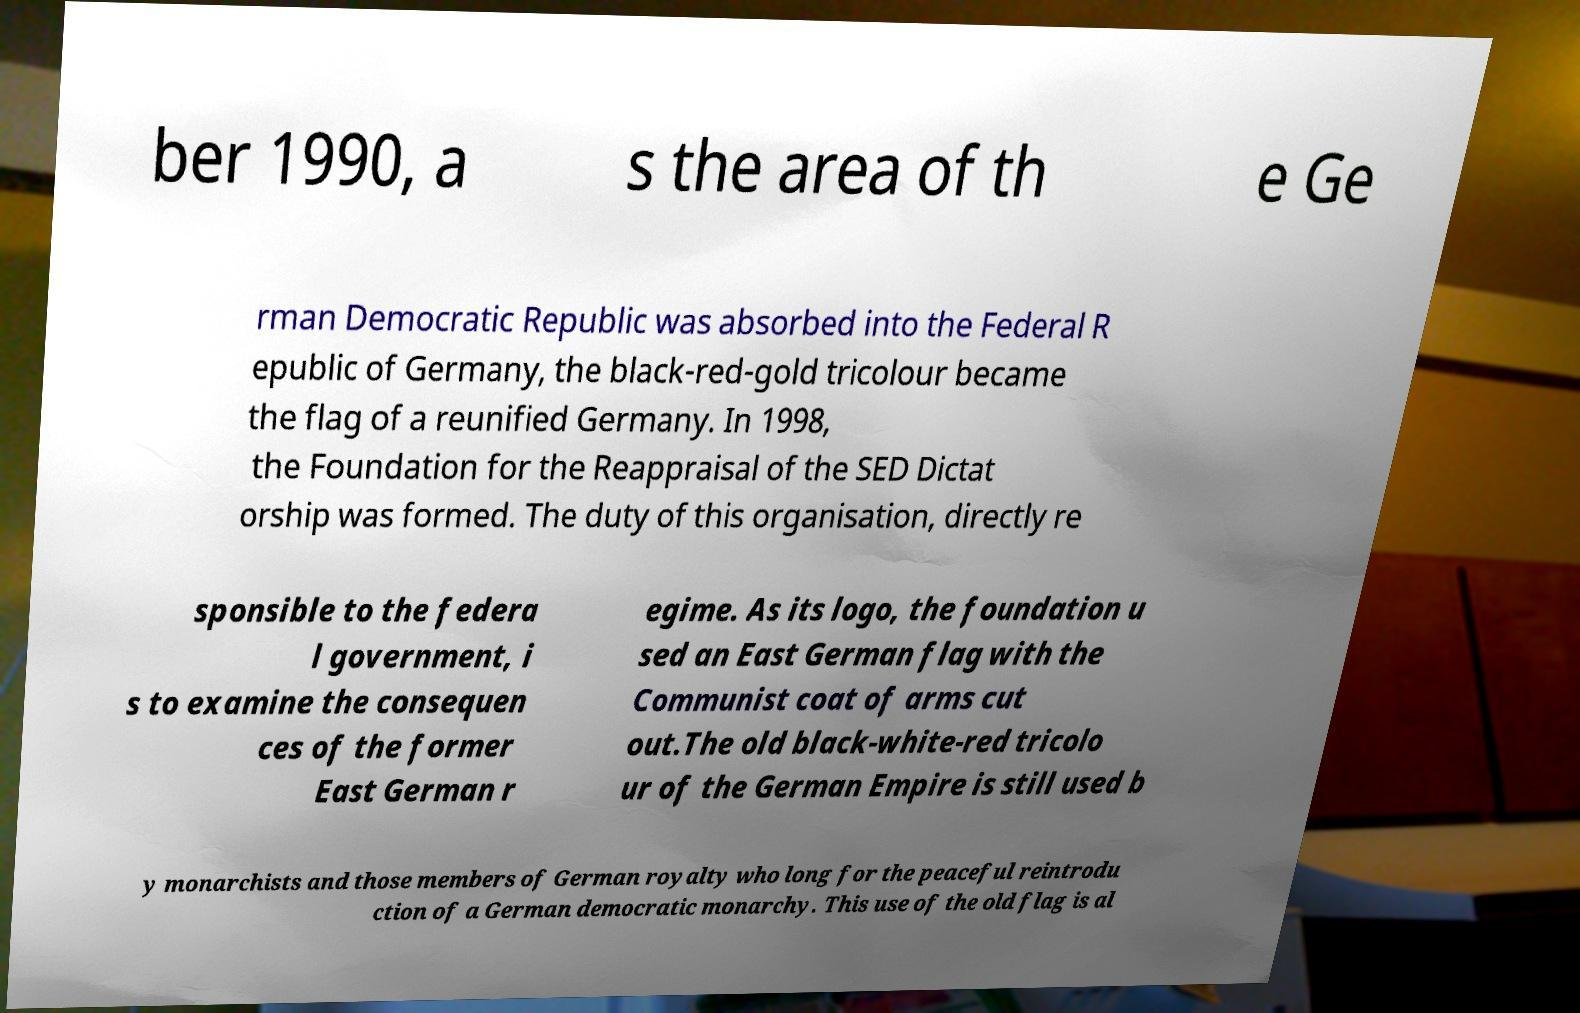Could you extract and type out the text from this image? ber 1990, a s the area of th e Ge rman Democratic Republic was absorbed into the Federal R epublic of Germany, the black-red-gold tricolour became the flag of a reunified Germany. In 1998, the Foundation for the Reappraisal of the SED Dictat orship was formed. The duty of this organisation, directly re sponsible to the federa l government, i s to examine the consequen ces of the former East German r egime. As its logo, the foundation u sed an East German flag with the Communist coat of arms cut out.The old black-white-red tricolo ur of the German Empire is still used b y monarchists and those members of German royalty who long for the peaceful reintrodu ction of a German democratic monarchy. This use of the old flag is al 